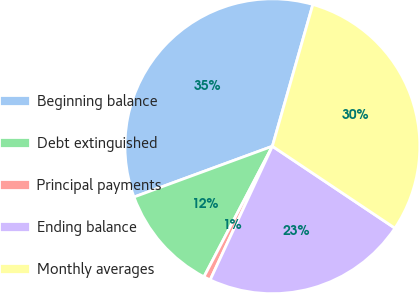<chart> <loc_0><loc_0><loc_500><loc_500><pie_chart><fcel>Beginning balance<fcel>Debt extinguished<fcel>Principal payments<fcel>Ending balance<fcel>Monthly averages<nl><fcel>35.02%<fcel>11.72%<fcel>0.75%<fcel>22.55%<fcel>29.95%<nl></chart> 